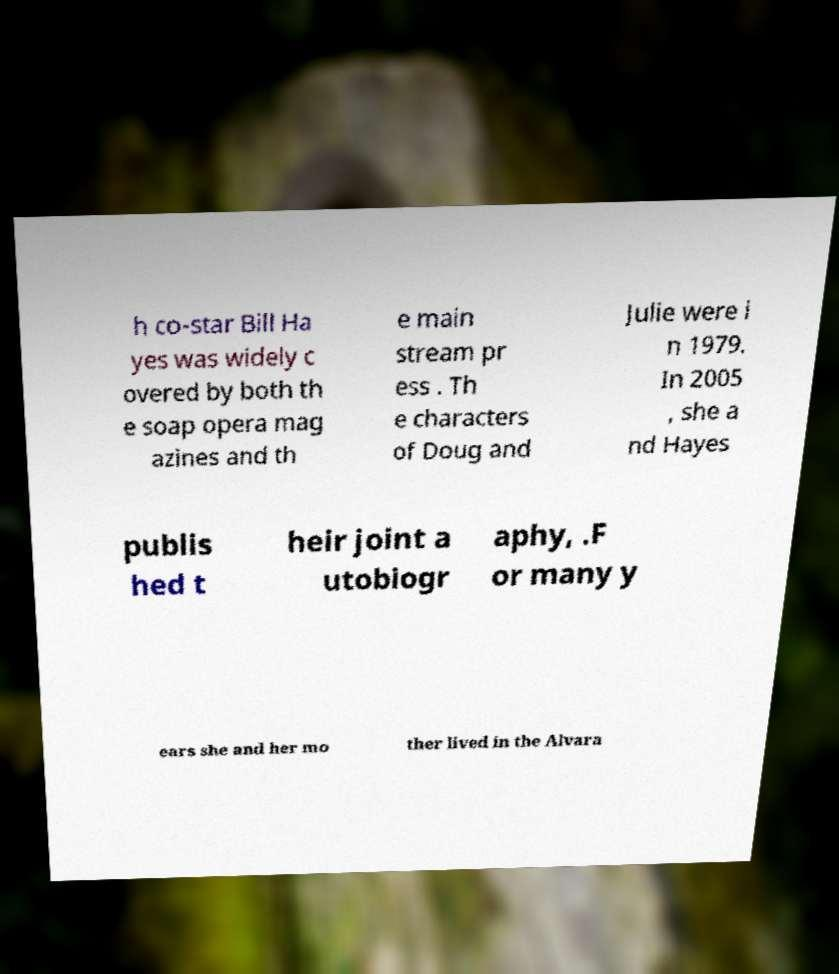What messages or text are displayed in this image? I need them in a readable, typed format. h co-star Bill Ha yes was widely c overed by both th e soap opera mag azines and th e main stream pr ess . Th e characters of Doug and Julie were i n 1979. In 2005 , she a nd Hayes publis hed t heir joint a utobiogr aphy, .F or many y ears she and her mo ther lived in the Alvara 